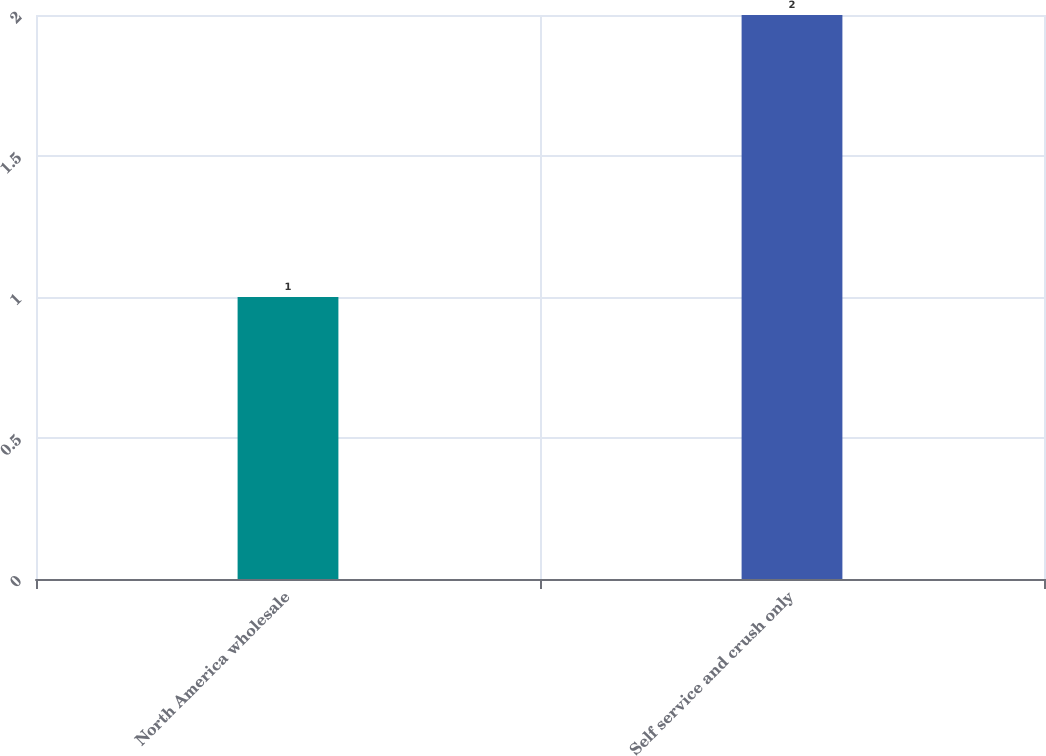Convert chart to OTSL. <chart><loc_0><loc_0><loc_500><loc_500><bar_chart><fcel>North America wholesale<fcel>Self service and crush only<nl><fcel>1<fcel>2<nl></chart> 